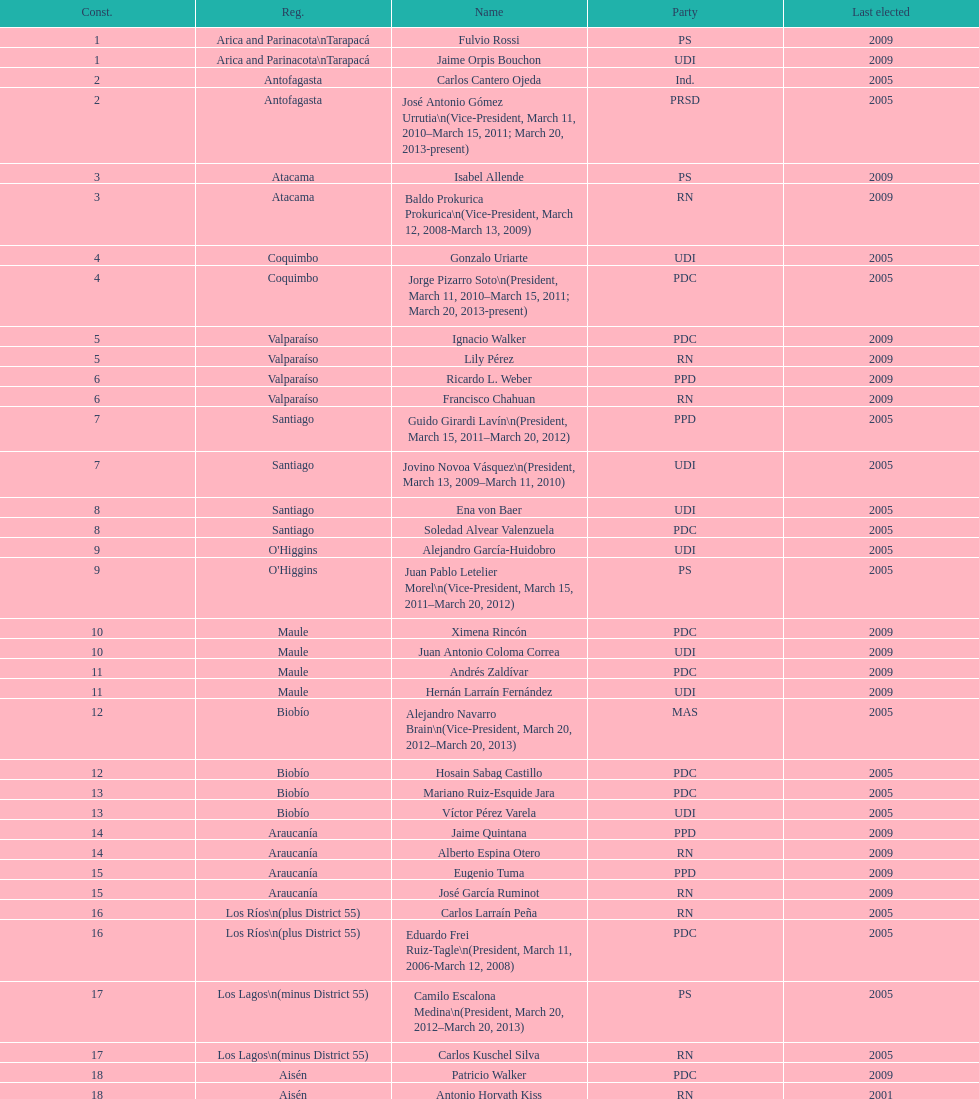What is the difference in years between constiuency 1 and 2? 4 years. 